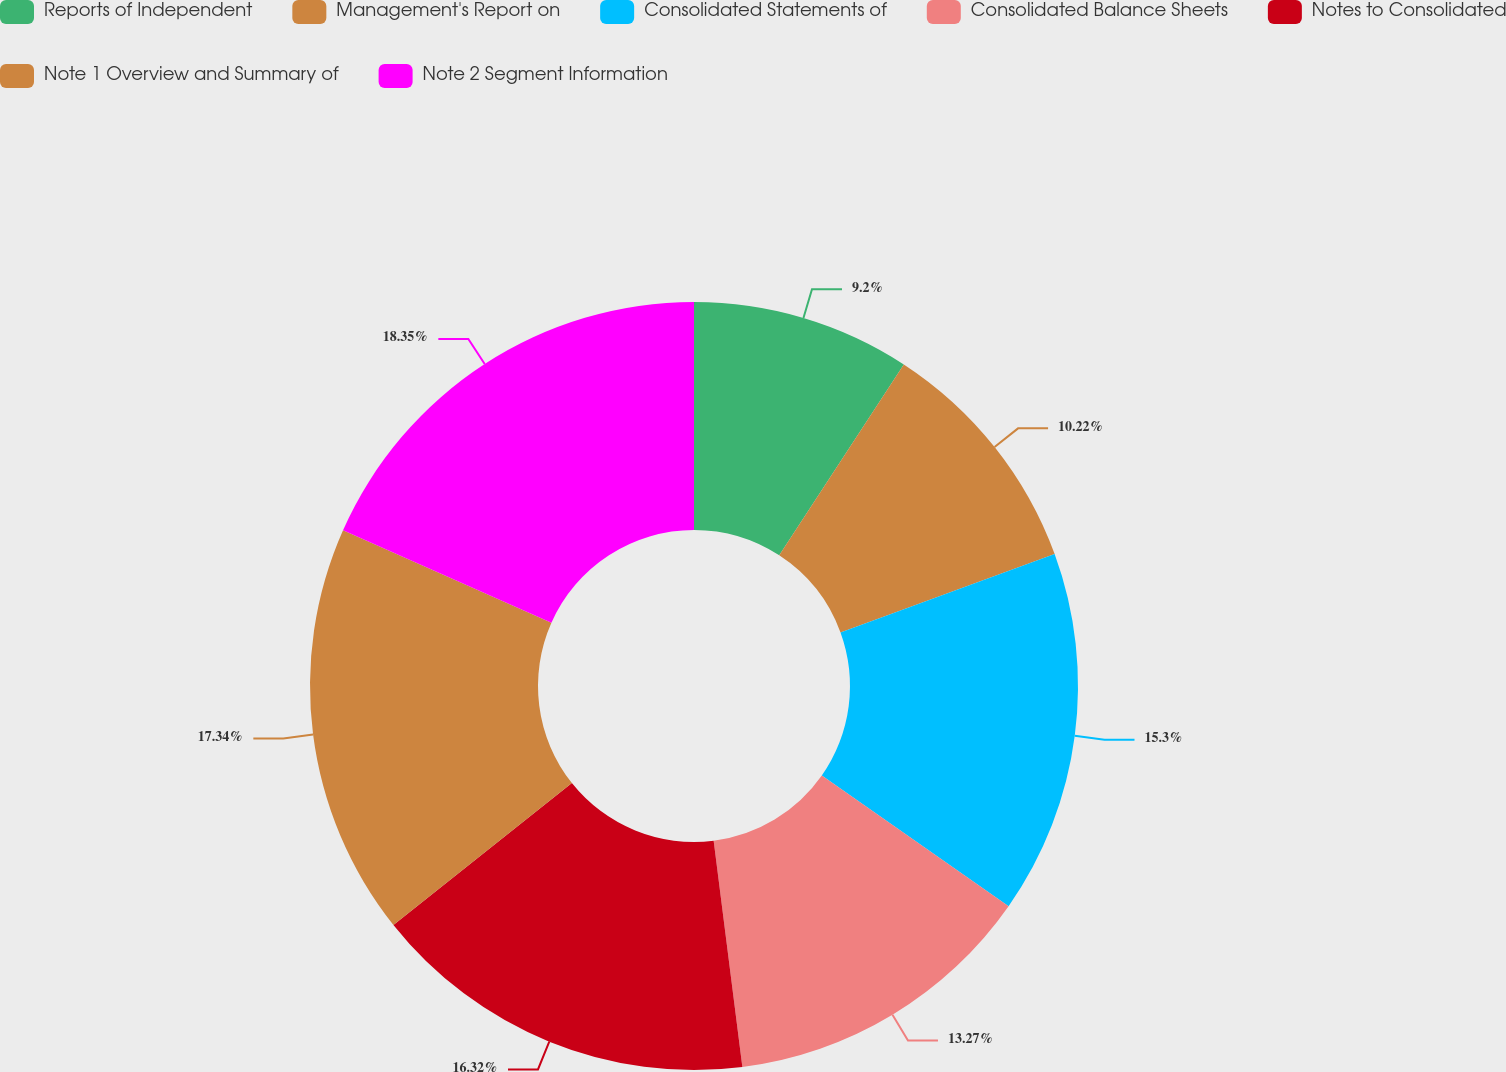Convert chart to OTSL. <chart><loc_0><loc_0><loc_500><loc_500><pie_chart><fcel>Reports of Independent<fcel>Management's Report on<fcel>Consolidated Statements of<fcel>Consolidated Balance Sheets<fcel>Notes to Consolidated<fcel>Note 1 Overview and Summary of<fcel>Note 2 Segment Information<nl><fcel>9.2%<fcel>10.22%<fcel>15.3%<fcel>13.27%<fcel>16.32%<fcel>17.34%<fcel>18.35%<nl></chart> 